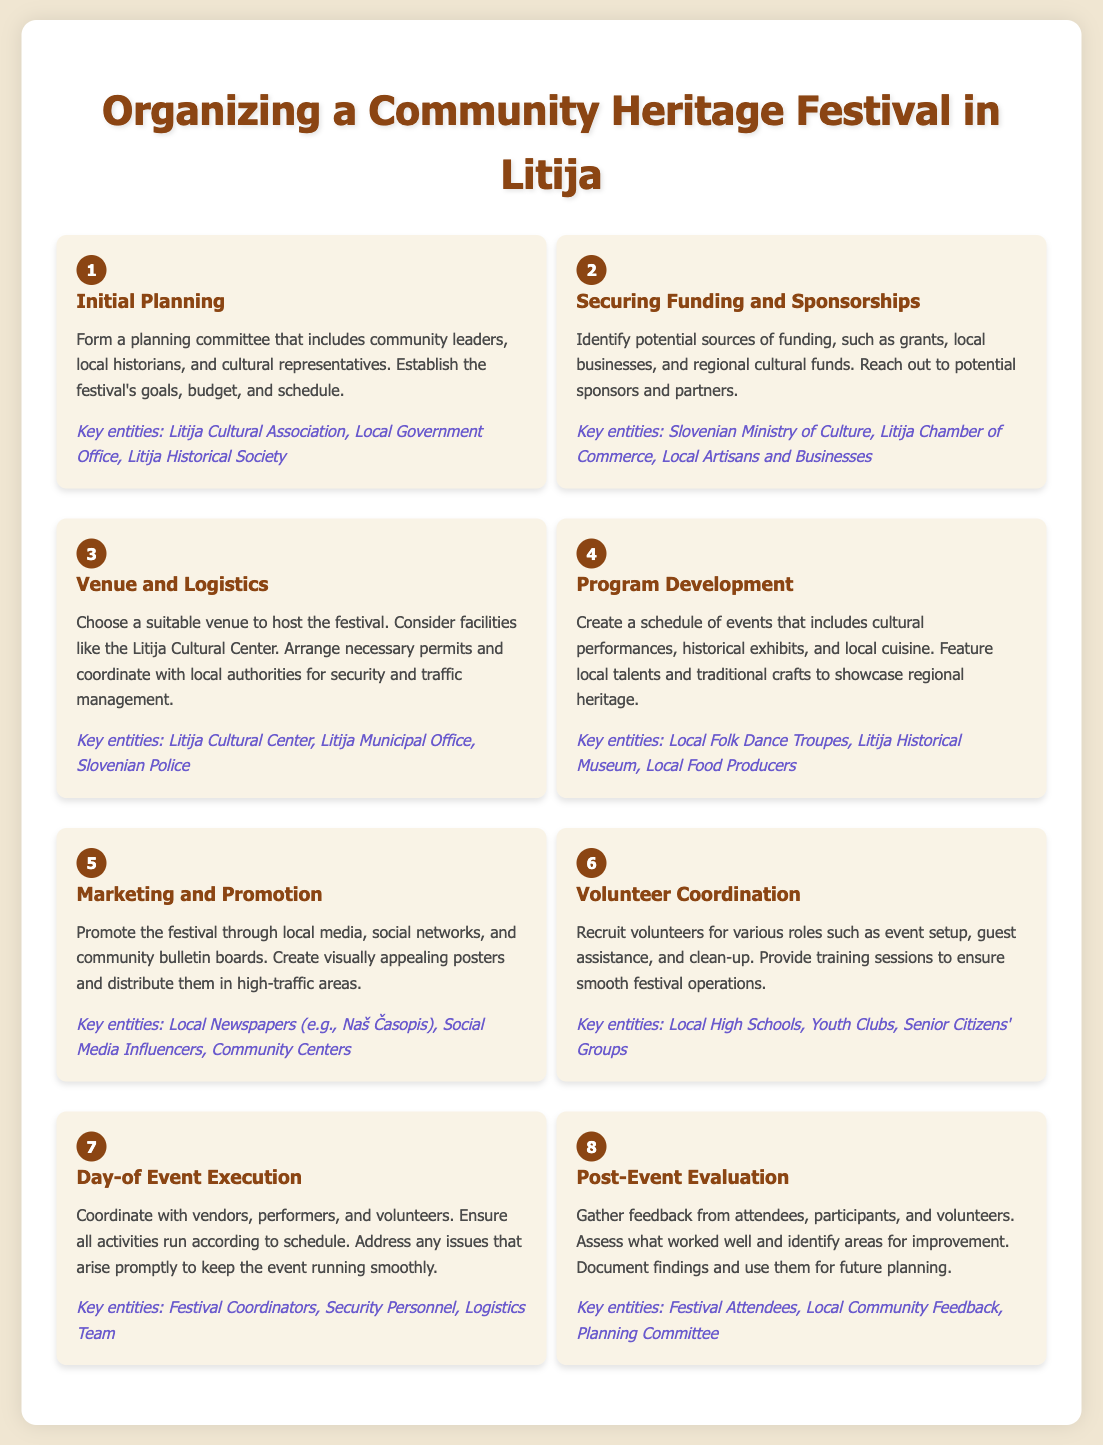what is the first step in organizing the festival? The first step mentioned in the document is "Initial Planning" which involves forming a planning committee.
Answer: Initial Planning who are the key entities involved in securing funding? The document states that the key entities involved in securing funding are the Slovenian Ministry of Culture, Litija Chamber of Commerce, and Local Artisans and Businesses.
Answer: Slovenian Ministry of Culture, Litija Chamber of Commerce, Local Artisans and Businesses how many total steps are involved in the festival organization process? The document outlines a total of eight steps for organizing the festival.
Answer: 8 what is the main purpose of the 'Post-Event Evaluation' step? The purpose is to gather feedback from attendees, participants, and volunteers to assess the event's success and areas for improvement.
Answer: Gather feedback which step includes marketing activities? The step that includes marketing activities is "Marketing and Promotion," which covers local media and social networks.
Answer: Marketing and Promotion who should be contacted for venue selection? For venue selection, the key entities mentioned include the Litija Cultural Center and Litija Municipal Office.
Answer: Litija Cultural Center, Litija Municipal Office what type of performances are featured in the festival program? The festival program features cultural performances, historical exhibits, and local cuisine, showcasing regional heritage.
Answer: Cultural performances what entities coordinate on the day of the event? The key entities coordinating on the day of the event include Festival Coordinators, Security Personnel, and the Logistics Team.
Answer: Festival Coordinators, Security Personnel, Logistics Team 